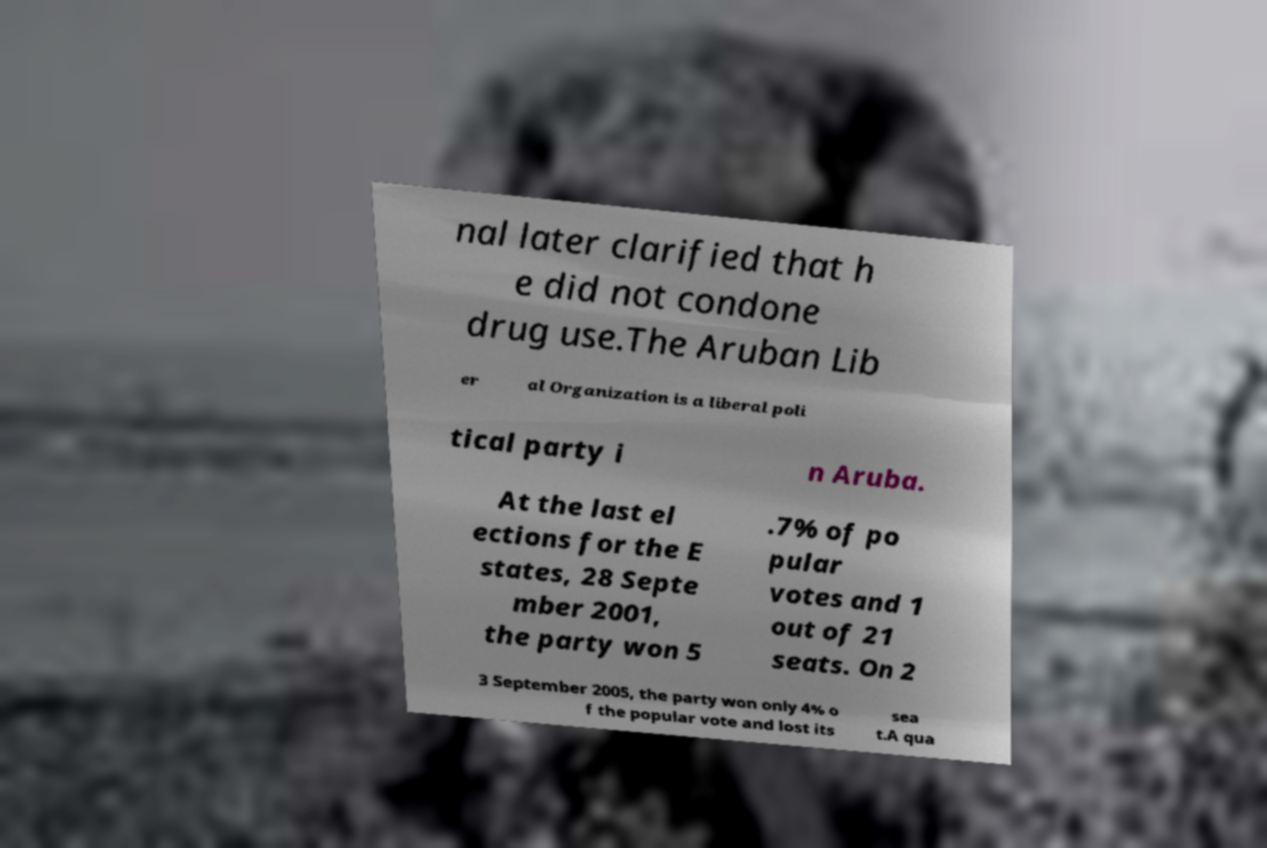Could you extract and type out the text from this image? nal later clarified that h e did not condone drug use.The Aruban Lib er al Organization is a liberal poli tical party i n Aruba. At the last el ections for the E states, 28 Septe mber 2001, the party won 5 .7% of po pular votes and 1 out of 21 seats. On 2 3 September 2005, the party won only 4% o f the popular vote and lost its sea t.A qua 